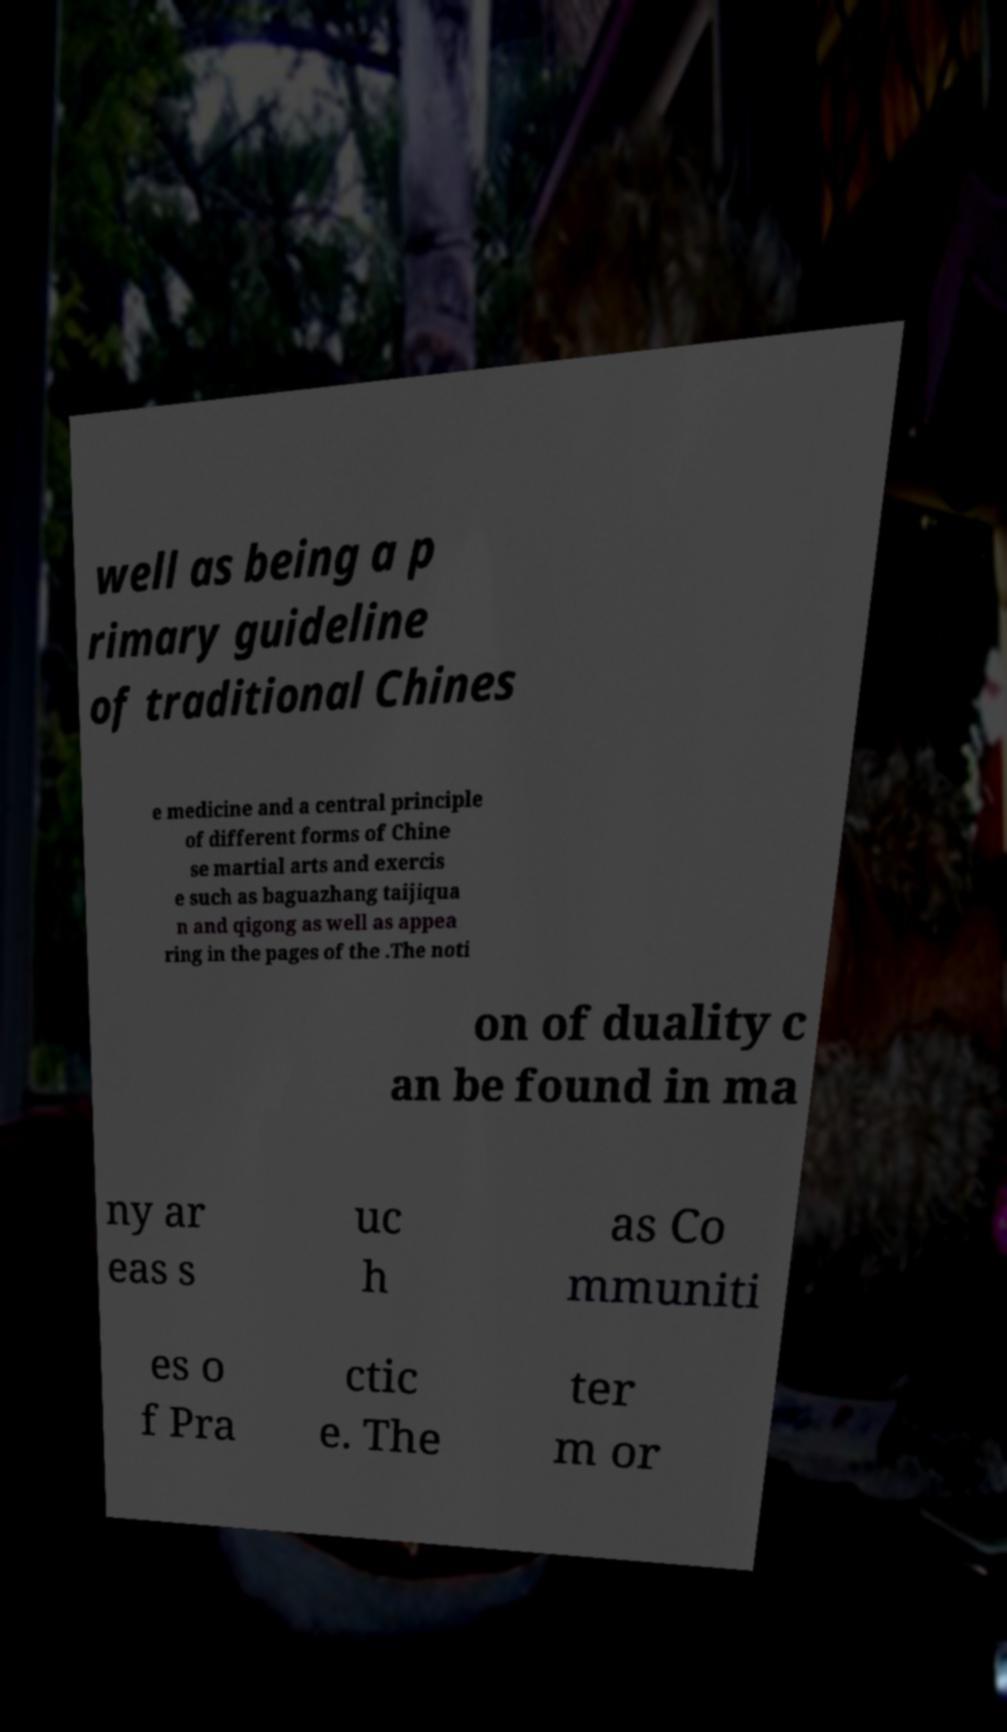There's text embedded in this image that I need extracted. Can you transcribe it verbatim? well as being a p rimary guideline of traditional Chines e medicine and a central principle of different forms of Chine se martial arts and exercis e such as baguazhang taijiqua n and qigong as well as appea ring in the pages of the .The noti on of duality c an be found in ma ny ar eas s uc h as Co mmuniti es o f Pra ctic e. The ter m or 